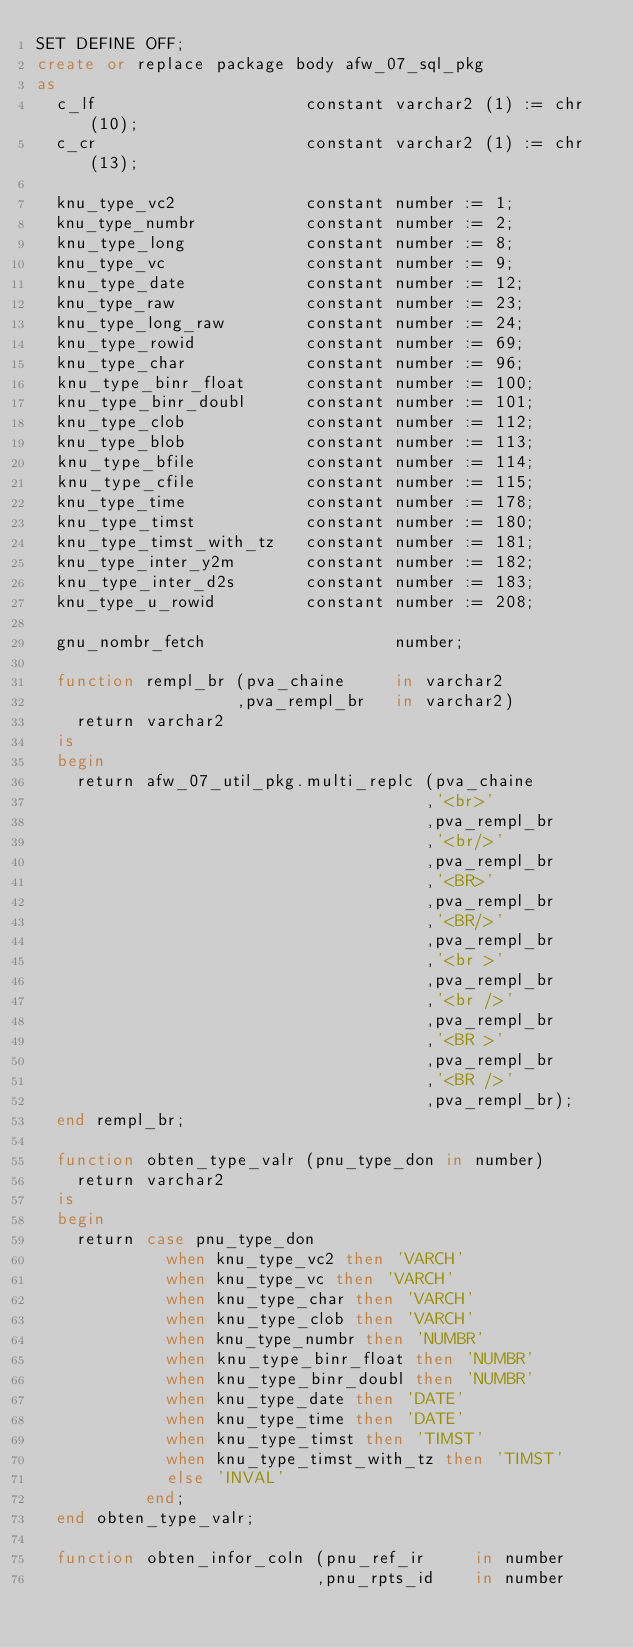Convert code to text. <code><loc_0><loc_0><loc_500><loc_500><_SQL_>SET DEFINE OFF;
create or replace package body afw_07_sql_pkg
as
  c_lf                     constant varchar2 (1) := chr (10);
  c_cr                     constant varchar2 (1) := chr (13);

  knu_type_vc2             constant number := 1;
  knu_type_numbr           constant number := 2;
  knu_type_long            constant number := 8;
  knu_type_vc              constant number := 9;
  knu_type_date            constant number := 12;
  knu_type_raw             constant number := 23;
  knu_type_long_raw        constant number := 24;
  knu_type_rowid           constant number := 69;
  knu_type_char            constant number := 96;
  knu_type_binr_float      constant number := 100;
  knu_type_binr_doubl      constant number := 101;
  knu_type_clob            constant number := 112;
  knu_type_blob            constant number := 113;
  knu_type_bfile           constant number := 114;
  knu_type_cfile           constant number := 115;
  knu_type_time            constant number := 178;
  knu_type_timst           constant number := 180;
  knu_type_timst_with_tz   constant number := 181;
  knu_type_inter_y2m       constant number := 182;
  knu_type_inter_d2s       constant number := 183;
  knu_type_u_rowid         constant number := 208;

  gnu_nombr_fetch                   number;

  function rempl_br (pva_chaine     in varchar2
                    ,pva_rempl_br   in varchar2)
    return varchar2
  is
  begin
    return afw_07_util_pkg.multi_replc (pva_chaine
                                       ,'<br>'
                                       ,pva_rempl_br
                                       ,'<br/>'
                                       ,pva_rempl_br
                                       ,'<BR>'
                                       ,pva_rempl_br
                                       ,'<BR/>'
                                       ,pva_rempl_br
                                       ,'<br >'
                                       ,pva_rempl_br
                                       ,'<br />'
                                       ,pva_rempl_br
                                       ,'<BR >'
                                       ,pva_rempl_br
                                       ,'<BR />'
                                       ,pva_rempl_br);
  end rempl_br;

  function obten_type_valr (pnu_type_don in number)
    return varchar2
  is
  begin
    return case pnu_type_don
             when knu_type_vc2 then 'VARCH'
             when knu_type_vc then 'VARCH'
             when knu_type_char then 'VARCH'
             when knu_type_clob then 'VARCH'
             when knu_type_numbr then 'NUMBR'
             when knu_type_binr_float then 'NUMBR'
             when knu_type_binr_doubl then 'NUMBR'
             when knu_type_date then 'DATE'
             when knu_type_time then 'DATE'
             when knu_type_timst then 'TIMST'
             when knu_type_timst_with_tz then 'TIMST'
             else 'INVAL'
           end;
  end obten_type_valr;

  function obten_infor_coln (pnu_ref_ir     in number
                            ,pnu_rpts_id    in number</code> 